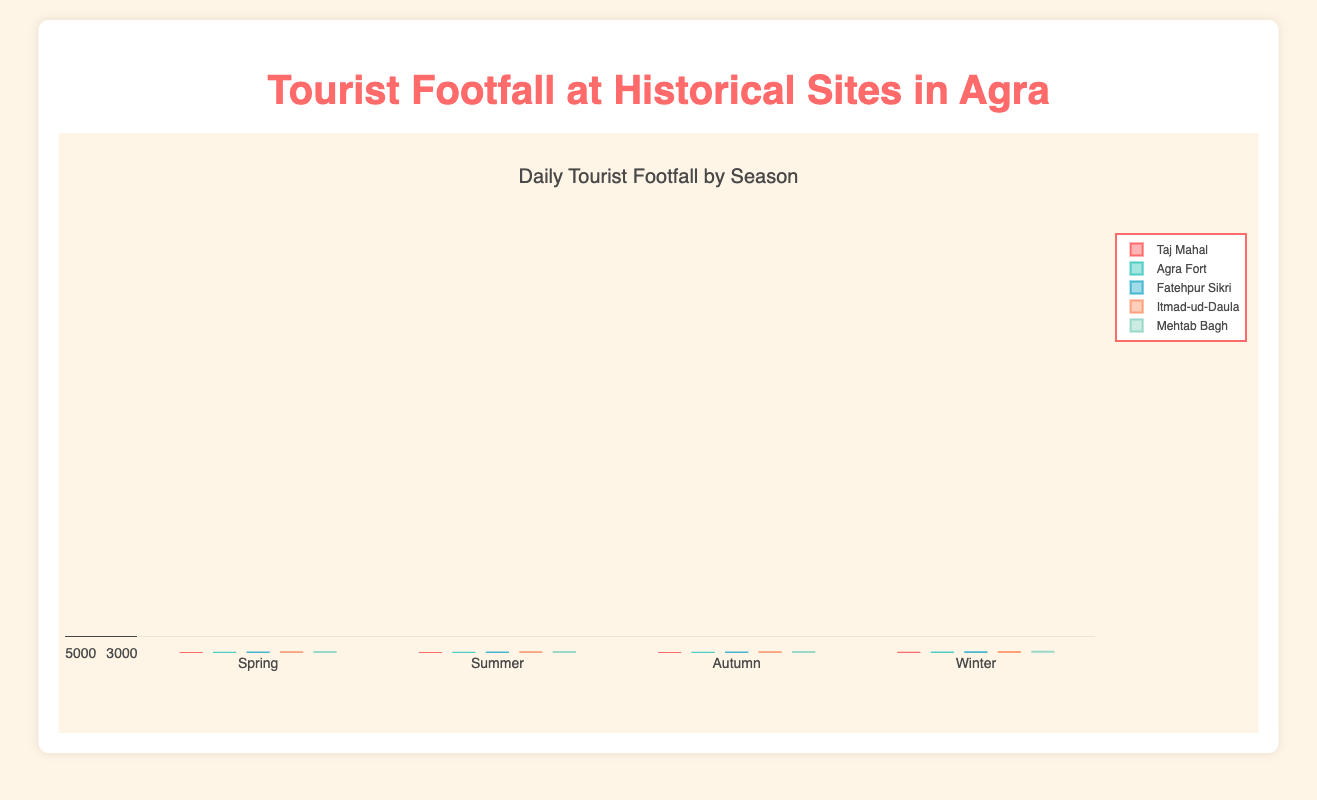What's the title of the figure? The title is usually found at the top of the figure and provides a brief description of the data being visualized. In this case, the title is "Daily Tourist Footfall by Season".
Answer: Daily Tourist Footfall by Season What is the range of the y-axis? The y-axis usually has a label indicating the range of values it can show. Here, the y-axis shows the number of tourists, with a range from 0 to 7000.
Answer: 0 to 7000 Which historical site has the highest median tourist footfall in Spring? To find the median, look for the line in the center of the box. For Spring, the Taj Mahal has the highest median compared to the other sites, indicated by the position of its median line.
Answer: Taj Mahal Which season generally has the lowest tourist footfall across all sites? Lowest footfall can be determined by the position of the boxes. Summer typically has the lowest overall boxes, indicating the lowest footfall across the sites.
Answer: Summer How does the median footfall at Taj Mahal in Winter compare to that in Summer? The central line of each box plot represents the median. For Taj Mahal, the median in Winter is much higher than in Summer (around 6200 compared to around 3200).
Answer: Median in Winter is higher What is the interquartile range (IQR) for Agra Fort in Autumn? The IQR is the difference between the third quartile (Q3) and the first quartile (Q1). For Agra Fort in Autumn, Q3 is around 3000 and Q1 is about 2800, so the IQR is 3000 - 2800 = 200.
Answer: 200 Which historical site shows the most variability in tourist footfall in Winter? Variability can be seen through the size of the box and the length of the whiskers. In Winter, Agra Fort shows the most variability as indicated by a larger box and longer whiskers.
Answer: Agra Fort In which season is the tourist footfall at Fatehpur Sikri more consistent? Consistency in data is indicated by a smaller box and shorter whiskers. For Fatehpur Sikri, Summer shows more consistency with much smaller boxes and whiskers compared to other seasons.
Answer: Summer How does the tourist footfall at Mehtab Bagh in Spring compare to that in Autumn? By comparing the position of the boxes, Mehtab Bagh in Spring has a higher median tourist footfall than in Autumn (Spring’s box is higher on the y-axis).
Answer: Higher in Spring 